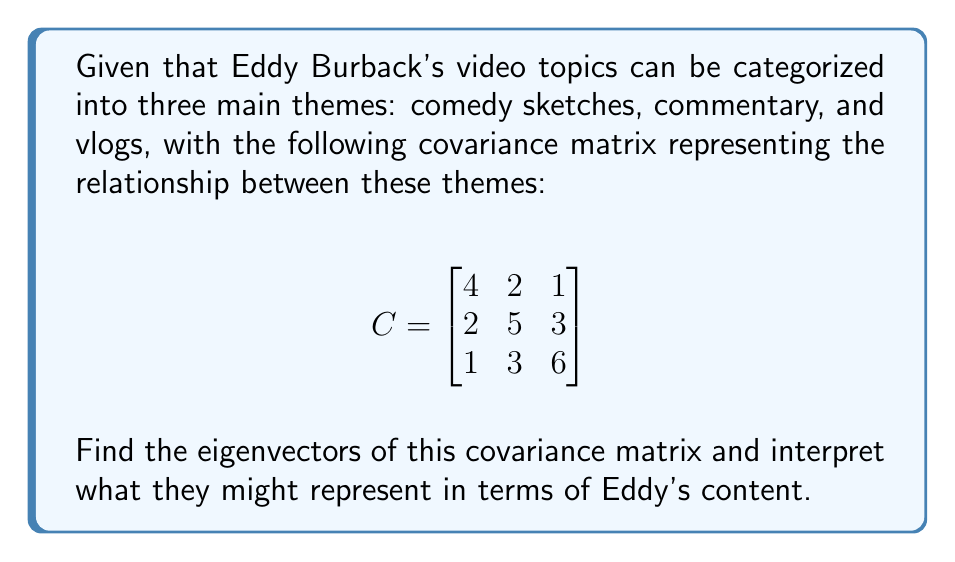Solve this math problem. To find the eigenvectors of the covariance matrix, we follow these steps:

1) First, we need to find the eigenvalues by solving the characteristic equation:
   $$det(C - \lambda I) = 0$$

2) Expanding this determinant:
   $$\begin{vmatrix}
   4-\lambda & 2 & 1 \\
   2 & 5-\lambda & 3 \\
   1 & 3 & 6-\lambda
   \end{vmatrix} = 0$$

3) This yields the characteristic polynomial:
   $$-\lambda^3 + 15\lambda^2 - 71\lambda + 105 = 0$$

4) Solving this equation (using a calculator or computer algebra system) gives us the eigenvalues:
   $$\lambda_1 \approx 8.30, \lambda_2 \approx 5.38, \lambda_3 \approx 1.32$$

5) For each eigenvalue, we solve $(C - \lambda I)v = 0$ to find the corresponding eigenvector:

   For $\lambda_1 \approx 8.30$:
   $$\begin{bmatrix}
   -4.30 & 2 & 1 \\
   2 & -3.30 & 3 \\
   1 & 3 & -2.30
   \end{bmatrix} \begin{bmatrix} v_1 \\ v_2 \\ v_3 \end{bmatrix} = \begin{bmatrix} 0 \\ 0 \\ 0 \end{bmatrix}$$

   Solving this system gives us the eigenvector: $v_1 \approx (0.36, 0.60, 0.71)$

   Similarly, for $\lambda_2 \approx 5.38$ and $\lambda_3 \approx 1.32$, we get:
   $v_2 \approx (0.68, -0.14, -0.72)$ and $v_3 \approx (0.64, -0.76, 0.11)$

6) Interpretation:
   - The first eigenvector $(0.36, 0.60, 0.71)$ represents a mix of all three themes, with slightly more emphasis on vlogs and commentary. This could represent Eddy's overall content style.
   - The second eigenvector $(0.68, -0.14, -0.72)$ contrasts comedy sketches against vlogs, possibly representing the spectrum from scripted to unscripted content.
   - The third eigenvector $(0.64, -0.76, 0.11)$ contrasts comedy sketches and commentary, potentially representing the spectrum from humorous to serious content.
Answer: Eigenvectors: $v_1 \approx (0.36, 0.60, 0.71)$, $v_2 \approx (0.68, -0.14, -0.72)$, $v_3 \approx (0.64, -0.76, 0.11)$ 